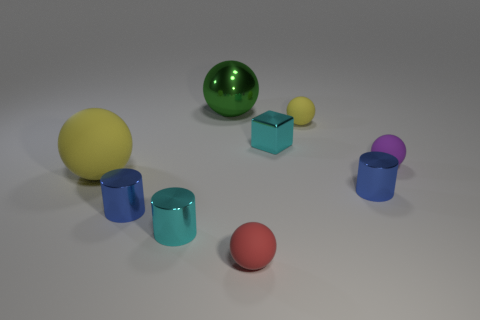Subtract all red balls. How many balls are left? 4 Subtract all green shiny balls. How many balls are left? 4 Subtract all blue spheres. Subtract all yellow cylinders. How many spheres are left? 5 Add 1 big green shiny things. How many objects exist? 10 Subtract all balls. How many objects are left? 4 Subtract 1 blue cylinders. How many objects are left? 8 Subtract all spheres. Subtract all tiny cubes. How many objects are left? 3 Add 3 red matte objects. How many red matte objects are left? 4 Add 3 red rubber objects. How many red rubber objects exist? 4 